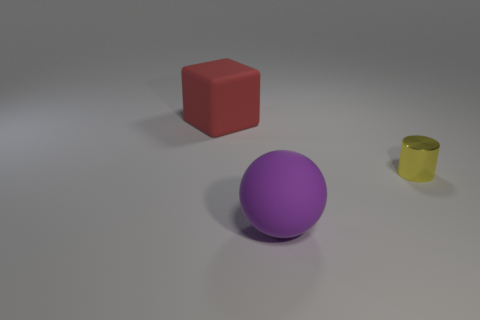Add 1 purple matte balls. How many objects exist? 4 Subtract all spheres. How many objects are left? 2 Add 1 balls. How many balls are left? 2 Add 2 big red things. How many big red things exist? 3 Subtract 0 gray spheres. How many objects are left? 3 Subtract all purple shiny spheres. Subtract all small yellow cylinders. How many objects are left? 2 